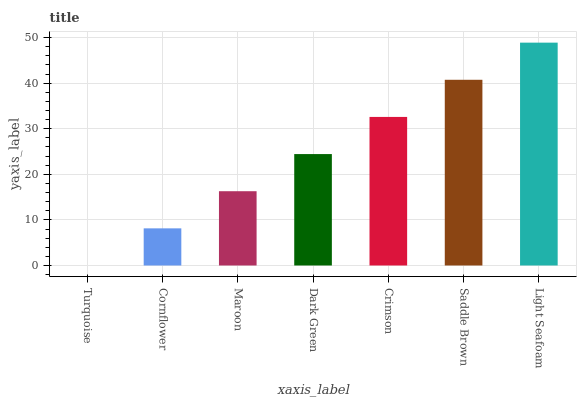Is Cornflower the minimum?
Answer yes or no. No. Is Cornflower the maximum?
Answer yes or no. No. Is Cornflower greater than Turquoise?
Answer yes or no. Yes. Is Turquoise less than Cornflower?
Answer yes or no. Yes. Is Turquoise greater than Cornflower?
Answer yes or no. No. Is Cornflower less than Turquoise?
Answer yes or no. No. Is Dark Green the high median?
Answer yes or no. Yes. Is Dark Green the low median?
Answer yes or no. Yes. Is Maroon the high median?
Answer yes or no. No. Is Maroon the low median?
Answer yes or no. No. 